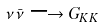Convert formula to latex. <formula><loc_0><loc_0><loc_500><loc_500>\nu \bar { \nu } \longrightarrow G _ { K K }</formula> 